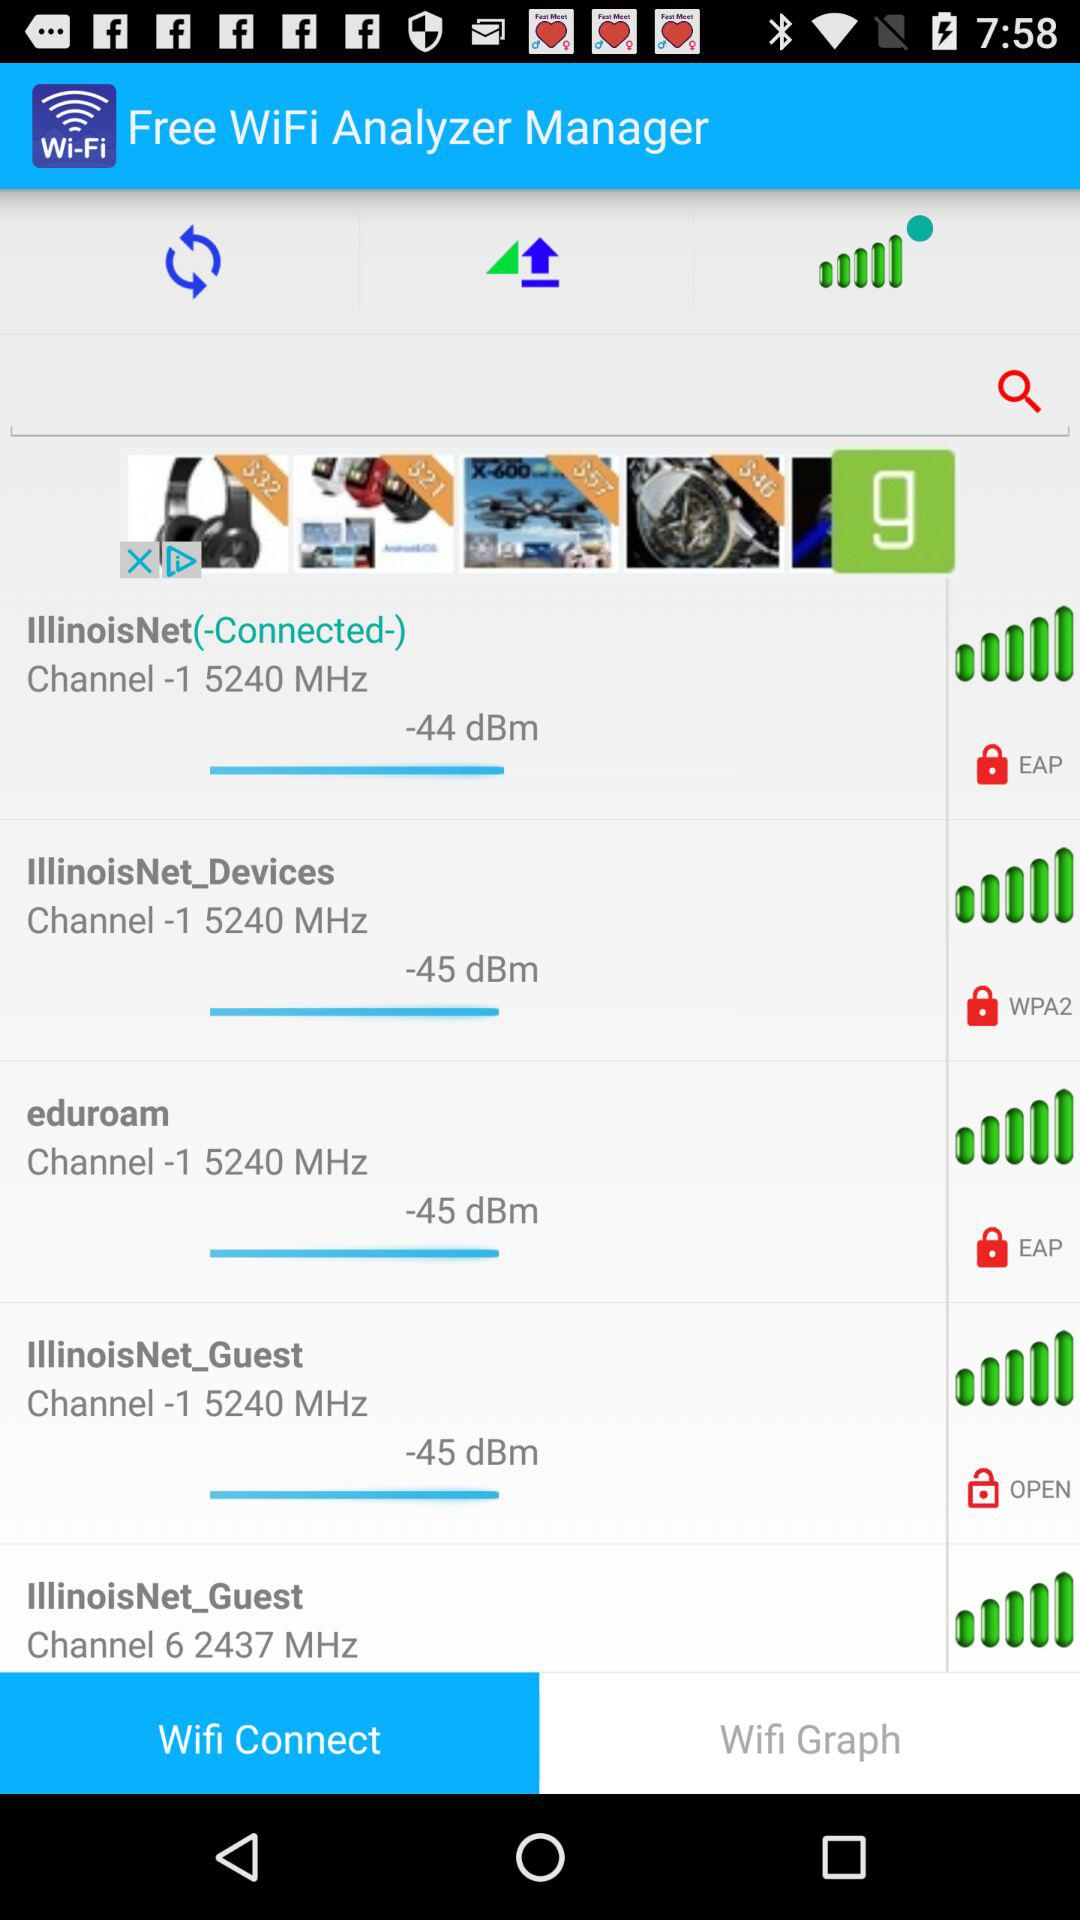What is the selected tab? The selected tab is "Wifi Connect". 